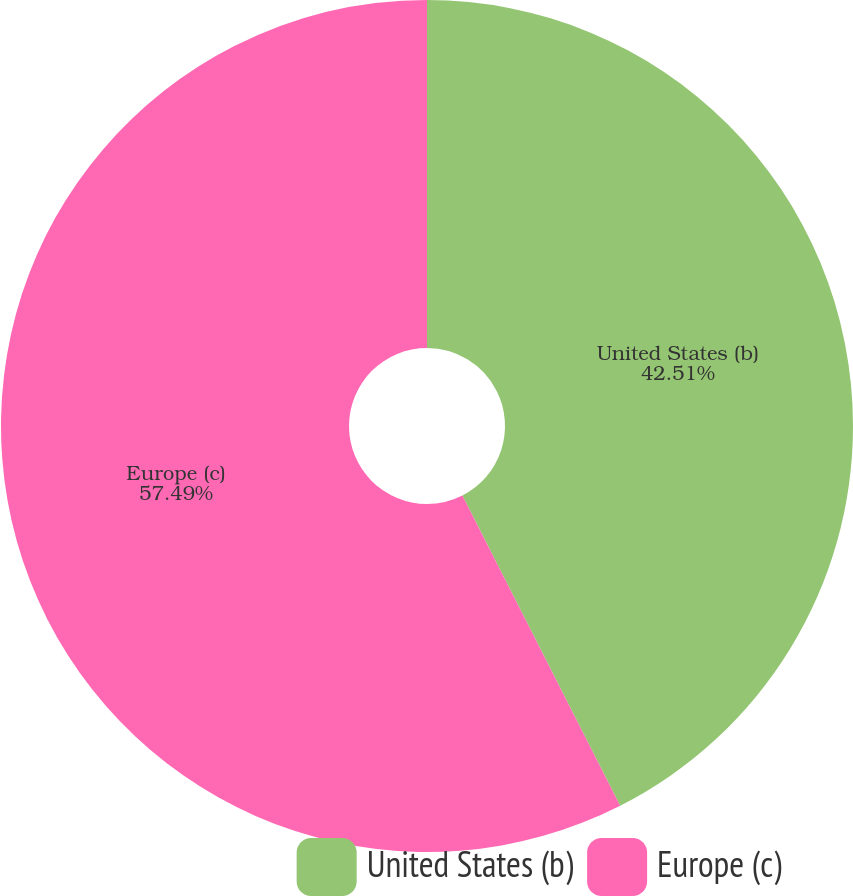Convert chart. <chart><loc_0><loc_0><loc_500><loc_500><pie_chart><fcel>United States (b)<fcel>Europe (c)<nl><fcel>42.51%<fcel>57.49%<nl></chart> 